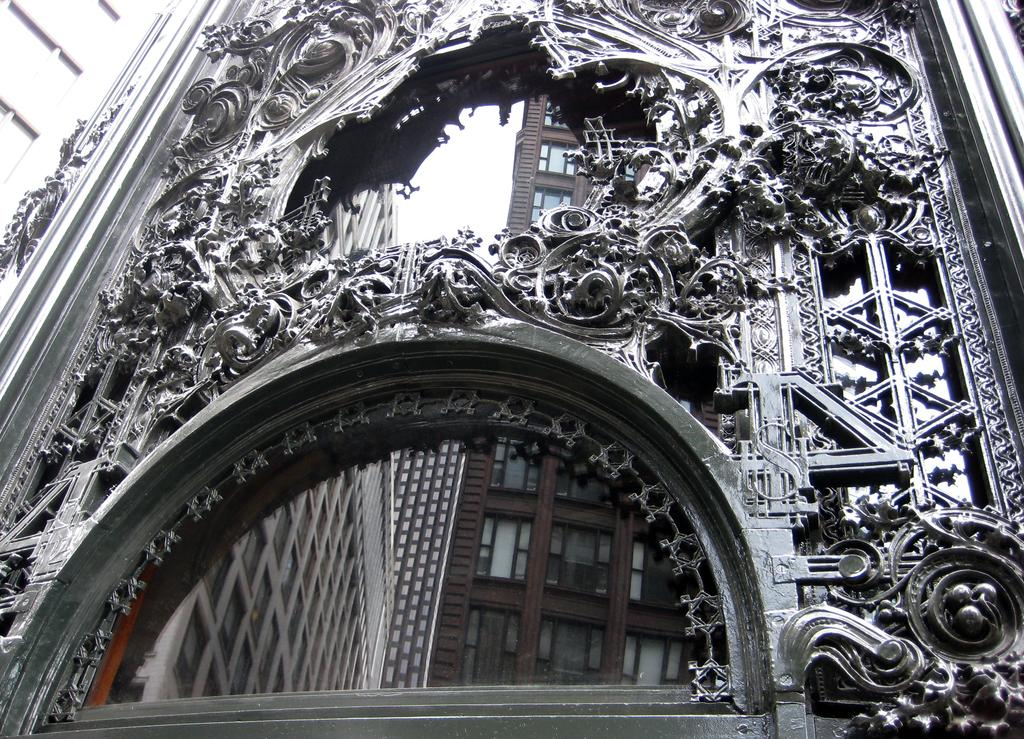What is on the wall in the image? There is a wall with designs in the image. What is unique about the wall in the image? The wall has mirrors on it. What do the mirrors reflect in the image? The mirrors reflect buildings with windows. How many giraffes are visible in the image? There are no giraffes present in the image. What type of fuel is being used by the buildings in the image? The image does not provide information about the type of fuel being used by the buildings. 